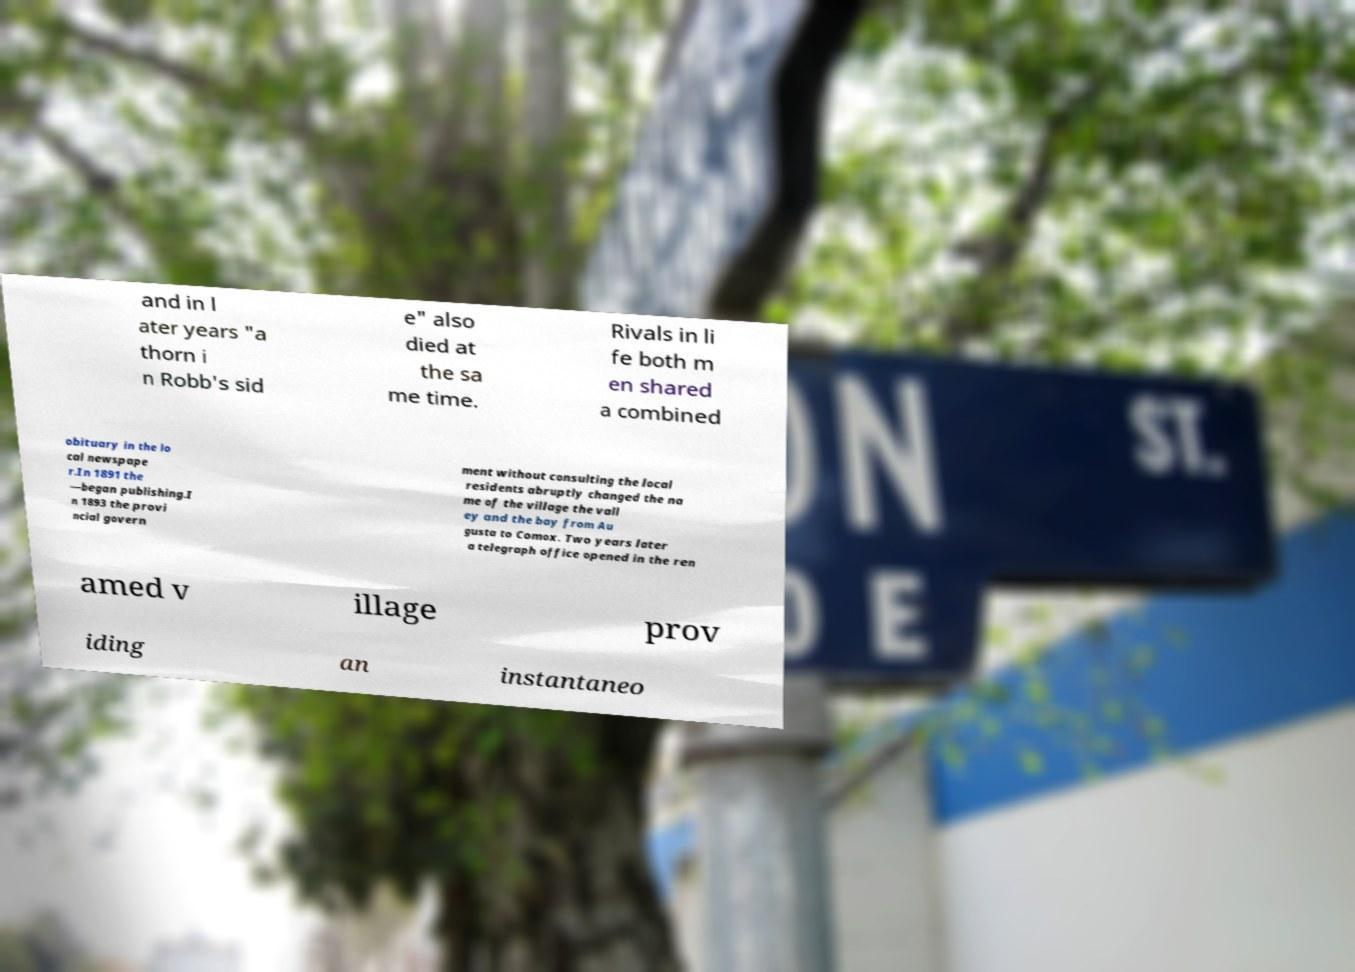Please identify and transcribe the text found in this image. and in l ater years "a thorn i n Robb's sid e" also died at the sa me time. Rivals in li fe both m en shared a combined obituary in the lo cal newspape r.In 1891 the —began publishing.I n 1893 the provi ncial govern ment without consulting the local residents abruptly changed the na me of the village the vall ey and the bay from Au gusta to Comox. Two years later a telegraph office opened in the ren amed v illage prov iding an instantaneo 